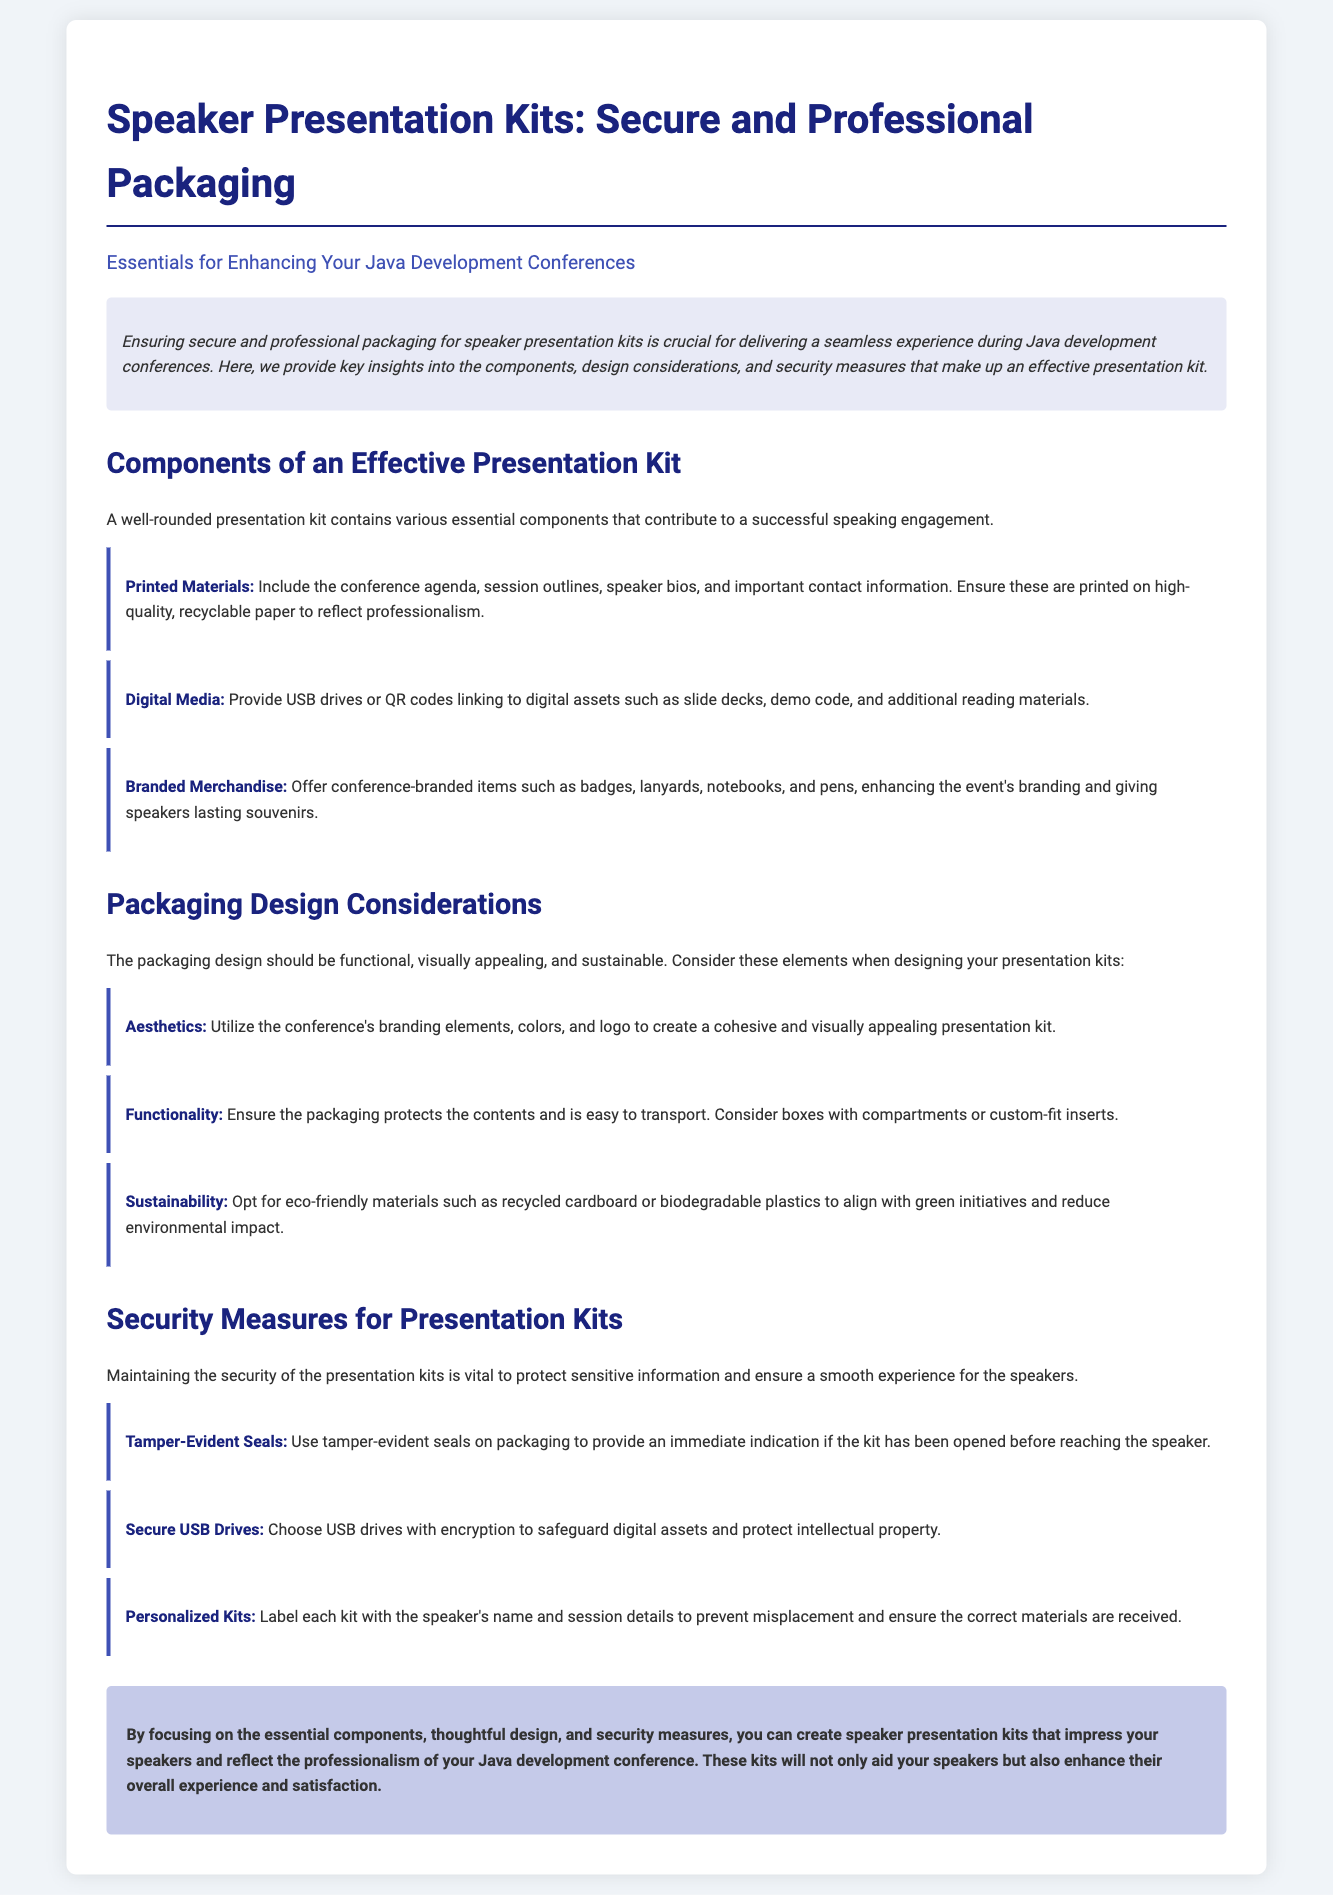What is the title of the document? The title of the document is stated at the top, summarizing its content focus.
Answer: Speaker Presentation Kits: Secure and Professional Packaging How many sections are there in the document? The document outlines multiple sections, highlighting the key topics covered within it.
Answer: Three What is included in the printed materials? The document specifies what to include in the printed materials of a presentation kit.
Answer: Conference agenda, session outlines, speaker bios, and important contact information What type of materials are suggested for sustainability? The document provides recommendations for sustainable materials used in packaging design.
Answer: Recycled cardboard or biodegradable plastics What is a security measure mentioned for USB drives? The document highlights an essential security feature for USB drives in the context of speaker presentation kits.
Answer: Encryption What should each personalized kit contain? The document states what should be included to personalize each kit effectively.
Answer: Speaker's name and session details What elements are mentioned for packaging design aesthetics? Aesthetic considerations are noted for the packaging design.
Answer: Conference's branding elements, colors, and logo Which aspect contributes to a seamless experience during conferences? The introductory section stresses an important factor related to speaker presentation kits and their effectiveness.
Answer: Secure and professional packaging What type of merchandise is suggested to enhance branding? The document lists specific items that can boost conference branding.
Answer: Conference-branded items such as badges, lanyards, notebooks, and pens 